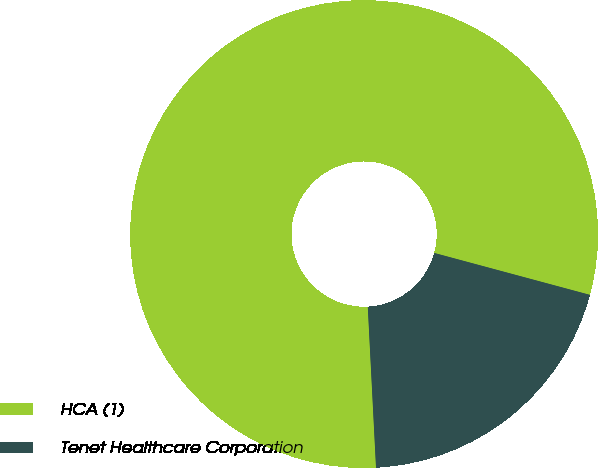Convert chart to OTSL. <chart><loc_0><loc_0><loc_500><loc_500><pie_chart><fcel>HCA (1)<fcel>Tenet Healthcare Corporation<nl><fcel>80.0%<fcel>20.0%<nl></chart> 